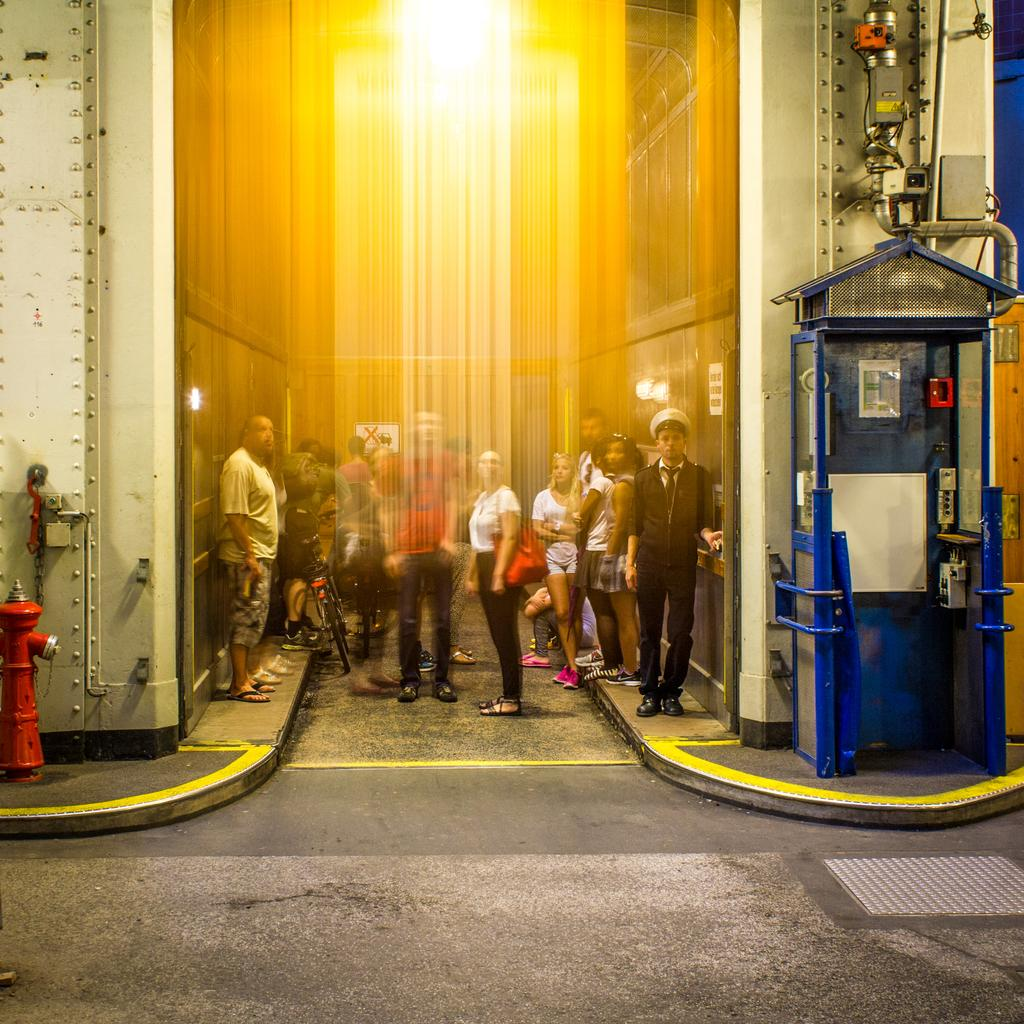What can be seen in the image in terms of human presence? There are people standing in the image. What type of structure is present in the image? There is a blue-colored booth in the image. What other object can be seen in the image? There is a red-colored fire hydrant in the image. What type of cave can be seen in the image? There is no cave present in the image. Is there a volcano visible in the image? There is no volcano present in the image. 